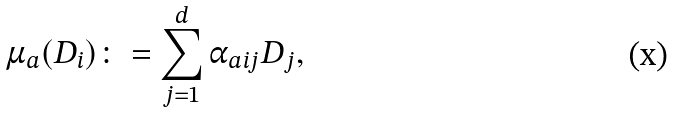Convert formula to latex. <formula><loc_0><loc_0><loc_500><loc_500>\mu _ { a } ( D _ { i } ) \colon = \sum _ { j = 1 } ^ { d } \alpha _ { a i j } D _ { j } ,</formula> 